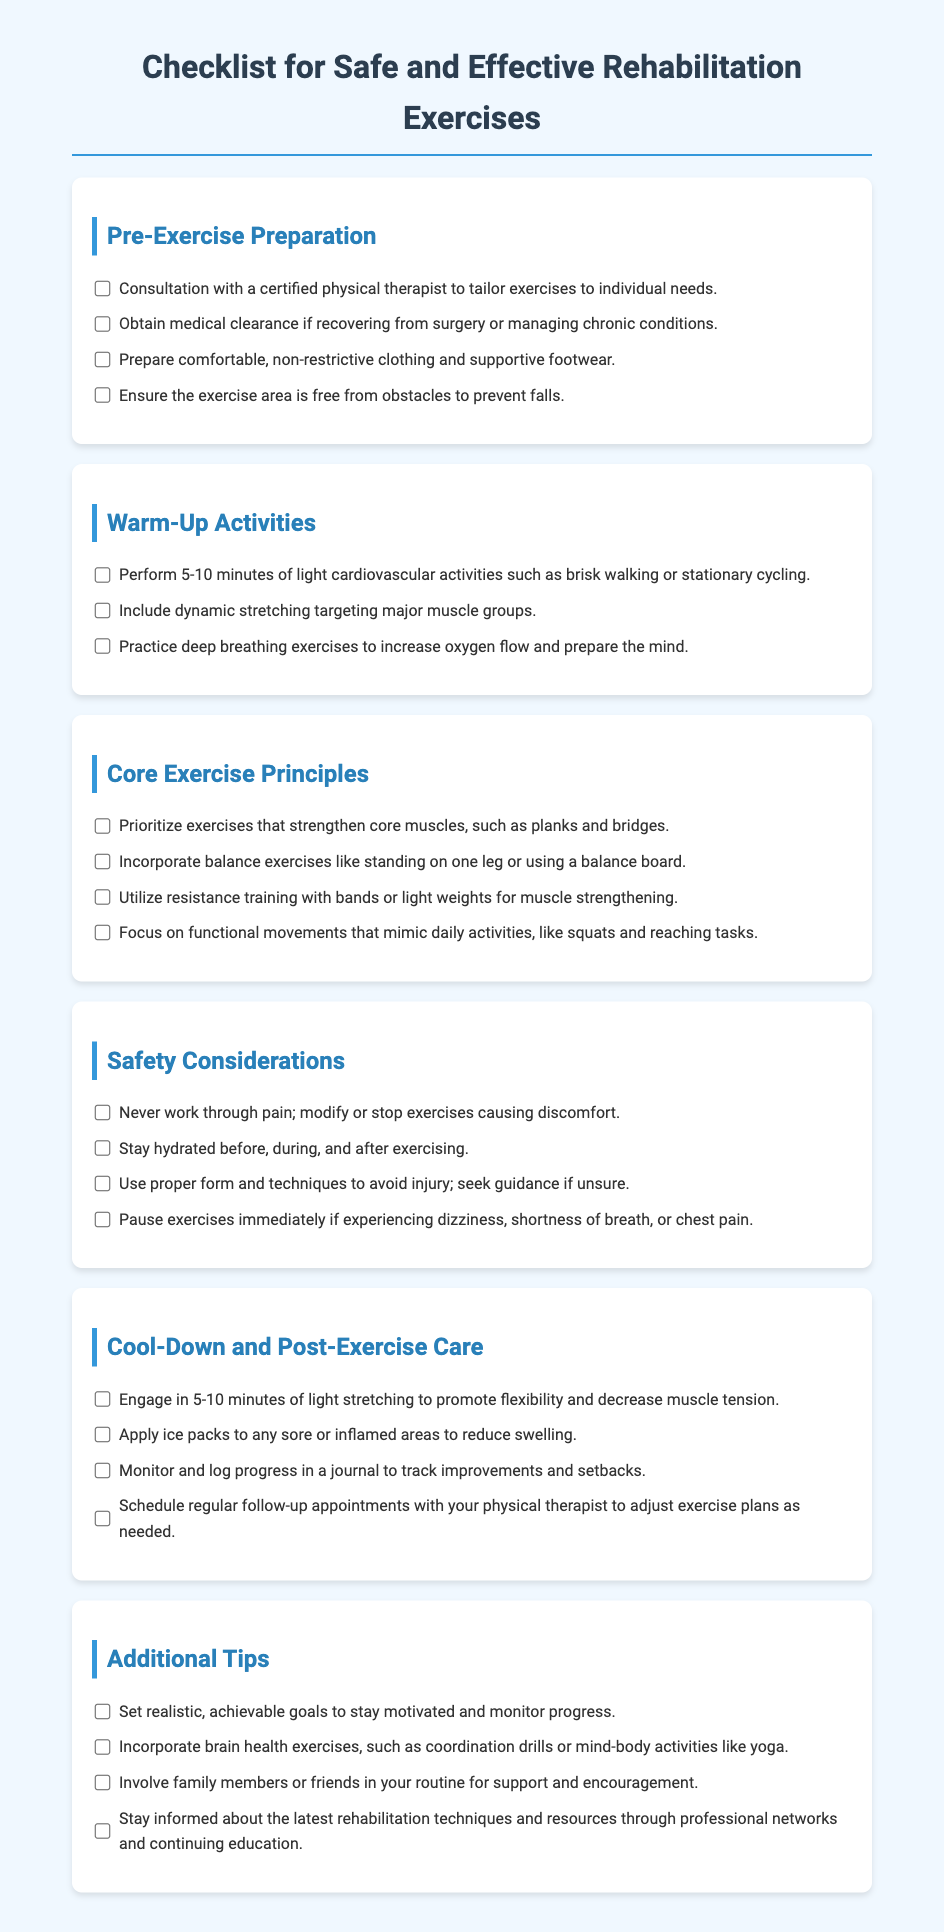What should you do before starting rehabilitation exercises? The checklist states you should consult with a certified physical therapist to tailor exercises to individual needs.
Answer: Consult with a certified physical therapist How long should warm-up activities last? The document mentions performing light cardiovascular activities for 5-10 minutes as part of warm-up activities.
Answer: 5-10 minutes What are two core exercise principles mentioned? The checklist lists prioritizing exercises that strengthen core muscles and incorporating balance exercises as core principles.
Answer: Strengthen core muscles and balance exercises What should you do if you experience dizziness during exercise? According to the safety considerations, you should pause exercises immediately if experiencing dizziness, shortness of breath, or chest pain.
Answer: Pause exercises immediately How many activities are listed under Cool-Down and Post-Exercise Care? There are four activities specified in the Cool-Down and Post-Exercise Care section of the checklist.
Answer: Four Which activities are suggested for brain health improvement? The additional tips mention incorporating coordination drills or mind-body activities like yoga to improve brain health.
Answer: Coordination drills or yoga 